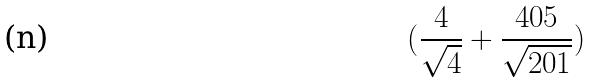<formula> <loc_0><loc_0><loc_500><loc_500>( \frac { 4 } { \sqrt { 4 } } + \frac { 4 0 5 } { \sqrt { 2 0 1 } } )</formula> 